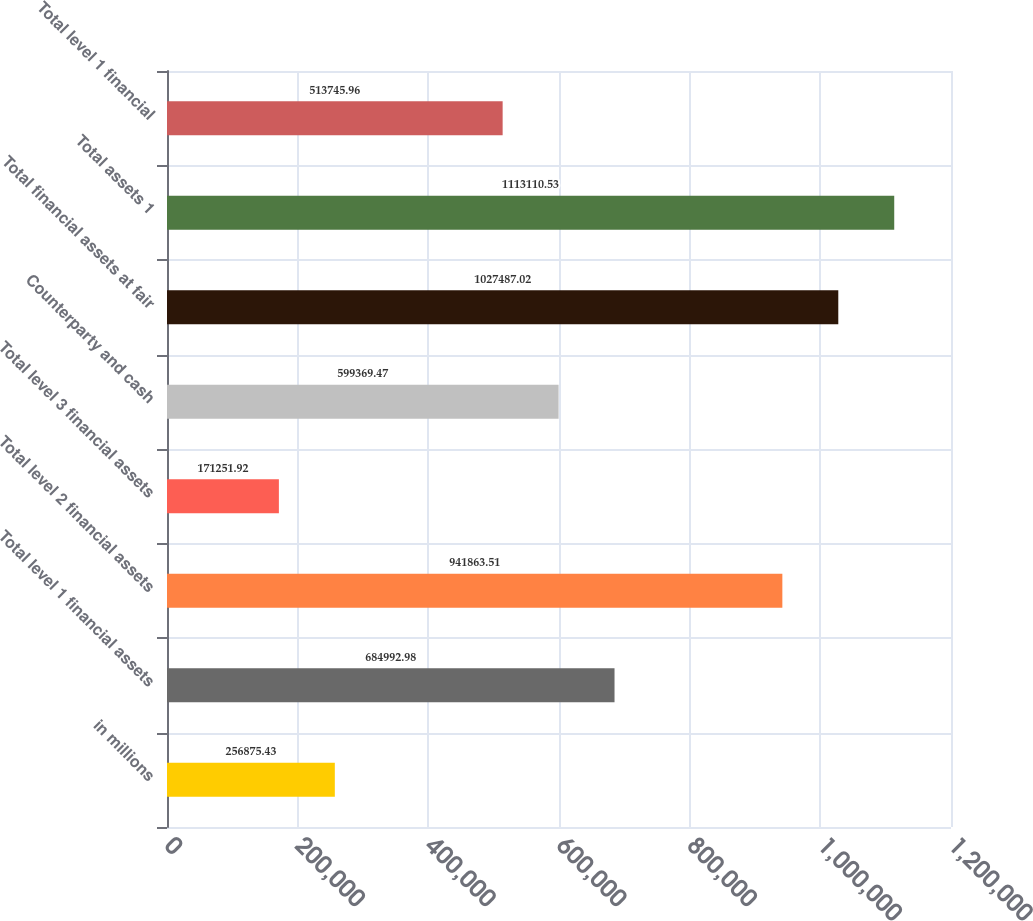Convert chart to OTSL. <chart><loc_0><loc_0><loc_500><loc_500><bar_chart><fcel>in millions<fcel>Total level 1 financial assets<fcel>Total level 2 financial assets<fcel>Total level 3 financial assets<fcel>Counterparty and cash<fcel>Total financial assets at fair<fcel>Total assets 1<fcel>Total level 1 financial<nl><fcel>256875<fcel>684993<fcel>941864<fcel>171252<fcel>599369<fcel>1.02749e+06<fcel>1.11311e+06<fcel>513746<nl></chart> 